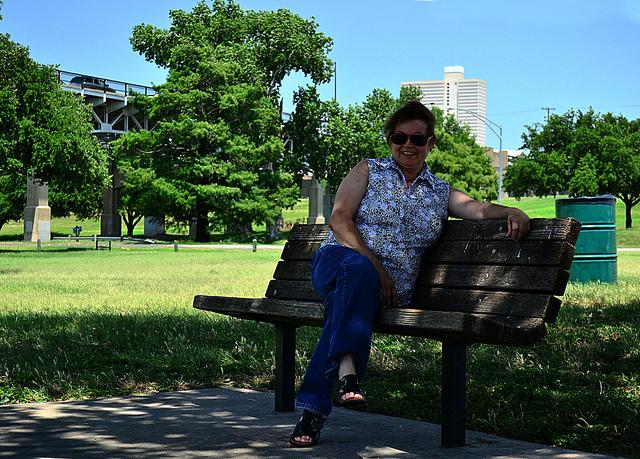What forms the shadow on the woman?

Choices:
A) tree
B) vehicle
C) building
D) animal tree 